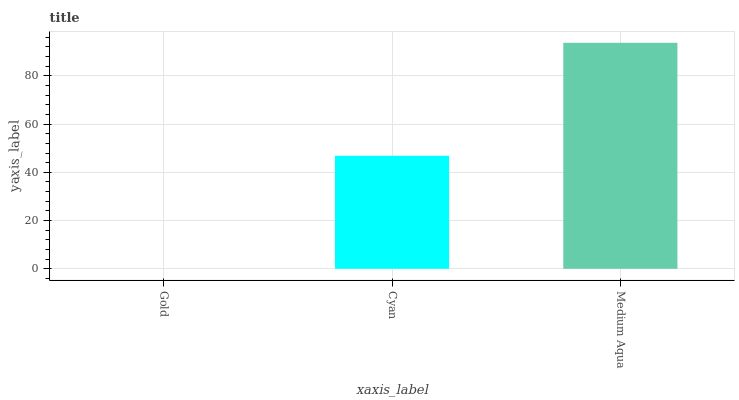Is Cyan the minimum?
Answer yes or no. No. Is Cyan the maximum?
Answer yes or no. No. Is Cyan greater than Gold?
Answer yes or no. Yes. Is Gold less than Cyan?
Answer yes or no. Yes. Is Gold greater than Cyan?
Answer yes or no. No. Is Cyan less than Gold?
Answer yes or no. No. Is Cyan the high median?
Answer yes or no. Yes. Is Cyan the low median?
Answer yes or no. Yes. Is Gold the high median?
Answer yes or no. No. Is Gold the low median?
Answer yes or no. No. 